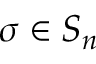<formula> <loc_0><loc_0><loc_500><loc_500>\sigma \in S _ { n }</formula> 